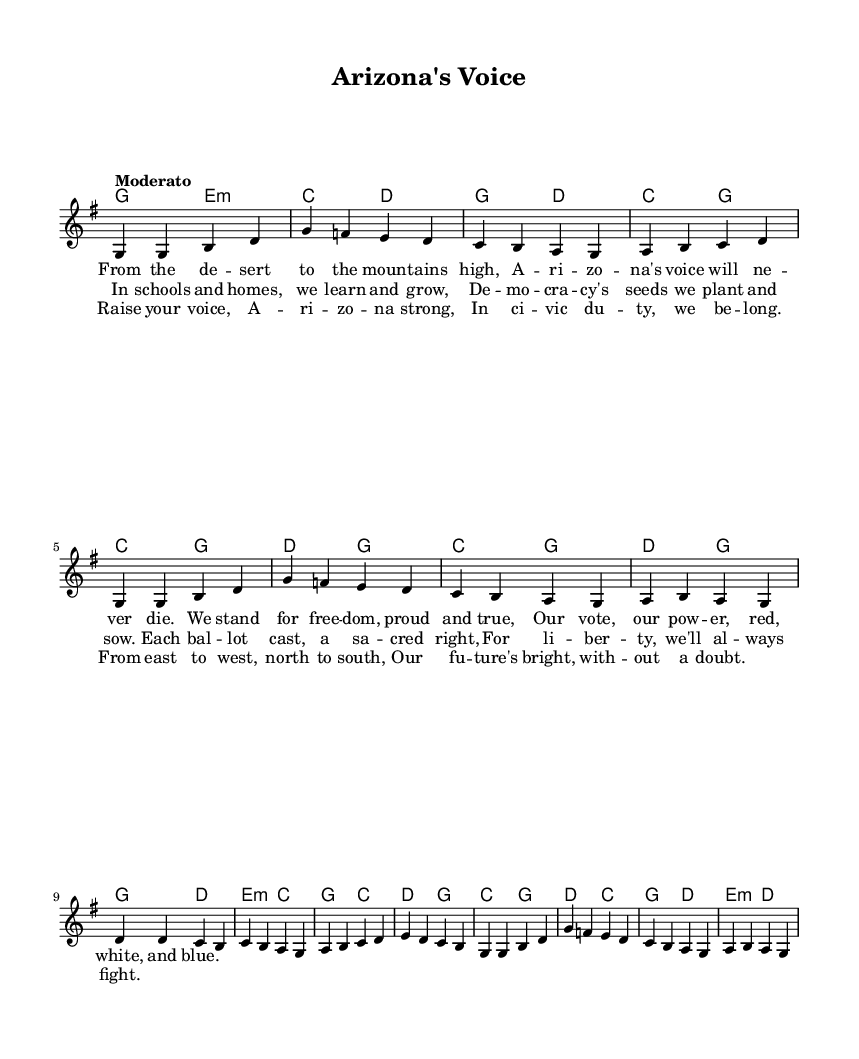What is the key signature of this music? The key signature indicated in the global section is G major, which has one sharp (F#).
Answer: G major What is the time signature of this music? The time signature shown in the global section is 4/4, which means there are four beats in each measure.
Answer: 4/4 What is the tempo marking for this piece? The tempo marking in the global section is "Moderato," indicating a moderate pace for the music.
Answer: Moderato How many verses are in the song? The sheet music includes two distinct verses and a chorus, indicating that there are two verses in total.
Answer: Two Describe the main theme of the lyrics. The lyrics emphasize civic responsibility, democracy, and the pride of Arizona's citizens participating in the electoral process, demonstrating the importance of voting and standing for freedom.
Answer: Civic duty and democracy What is the structure of the song? The song follows a clear structure: it consists of two verses followed by a chorus, which is typical for folk songs, emphasizing repetition and collective participation.
Answer: Verse, Verse, Chorus Identify the first note of the melody. The melody starts with the note G, as clearly indicated at the beginning of the melody section.
Answer: G 